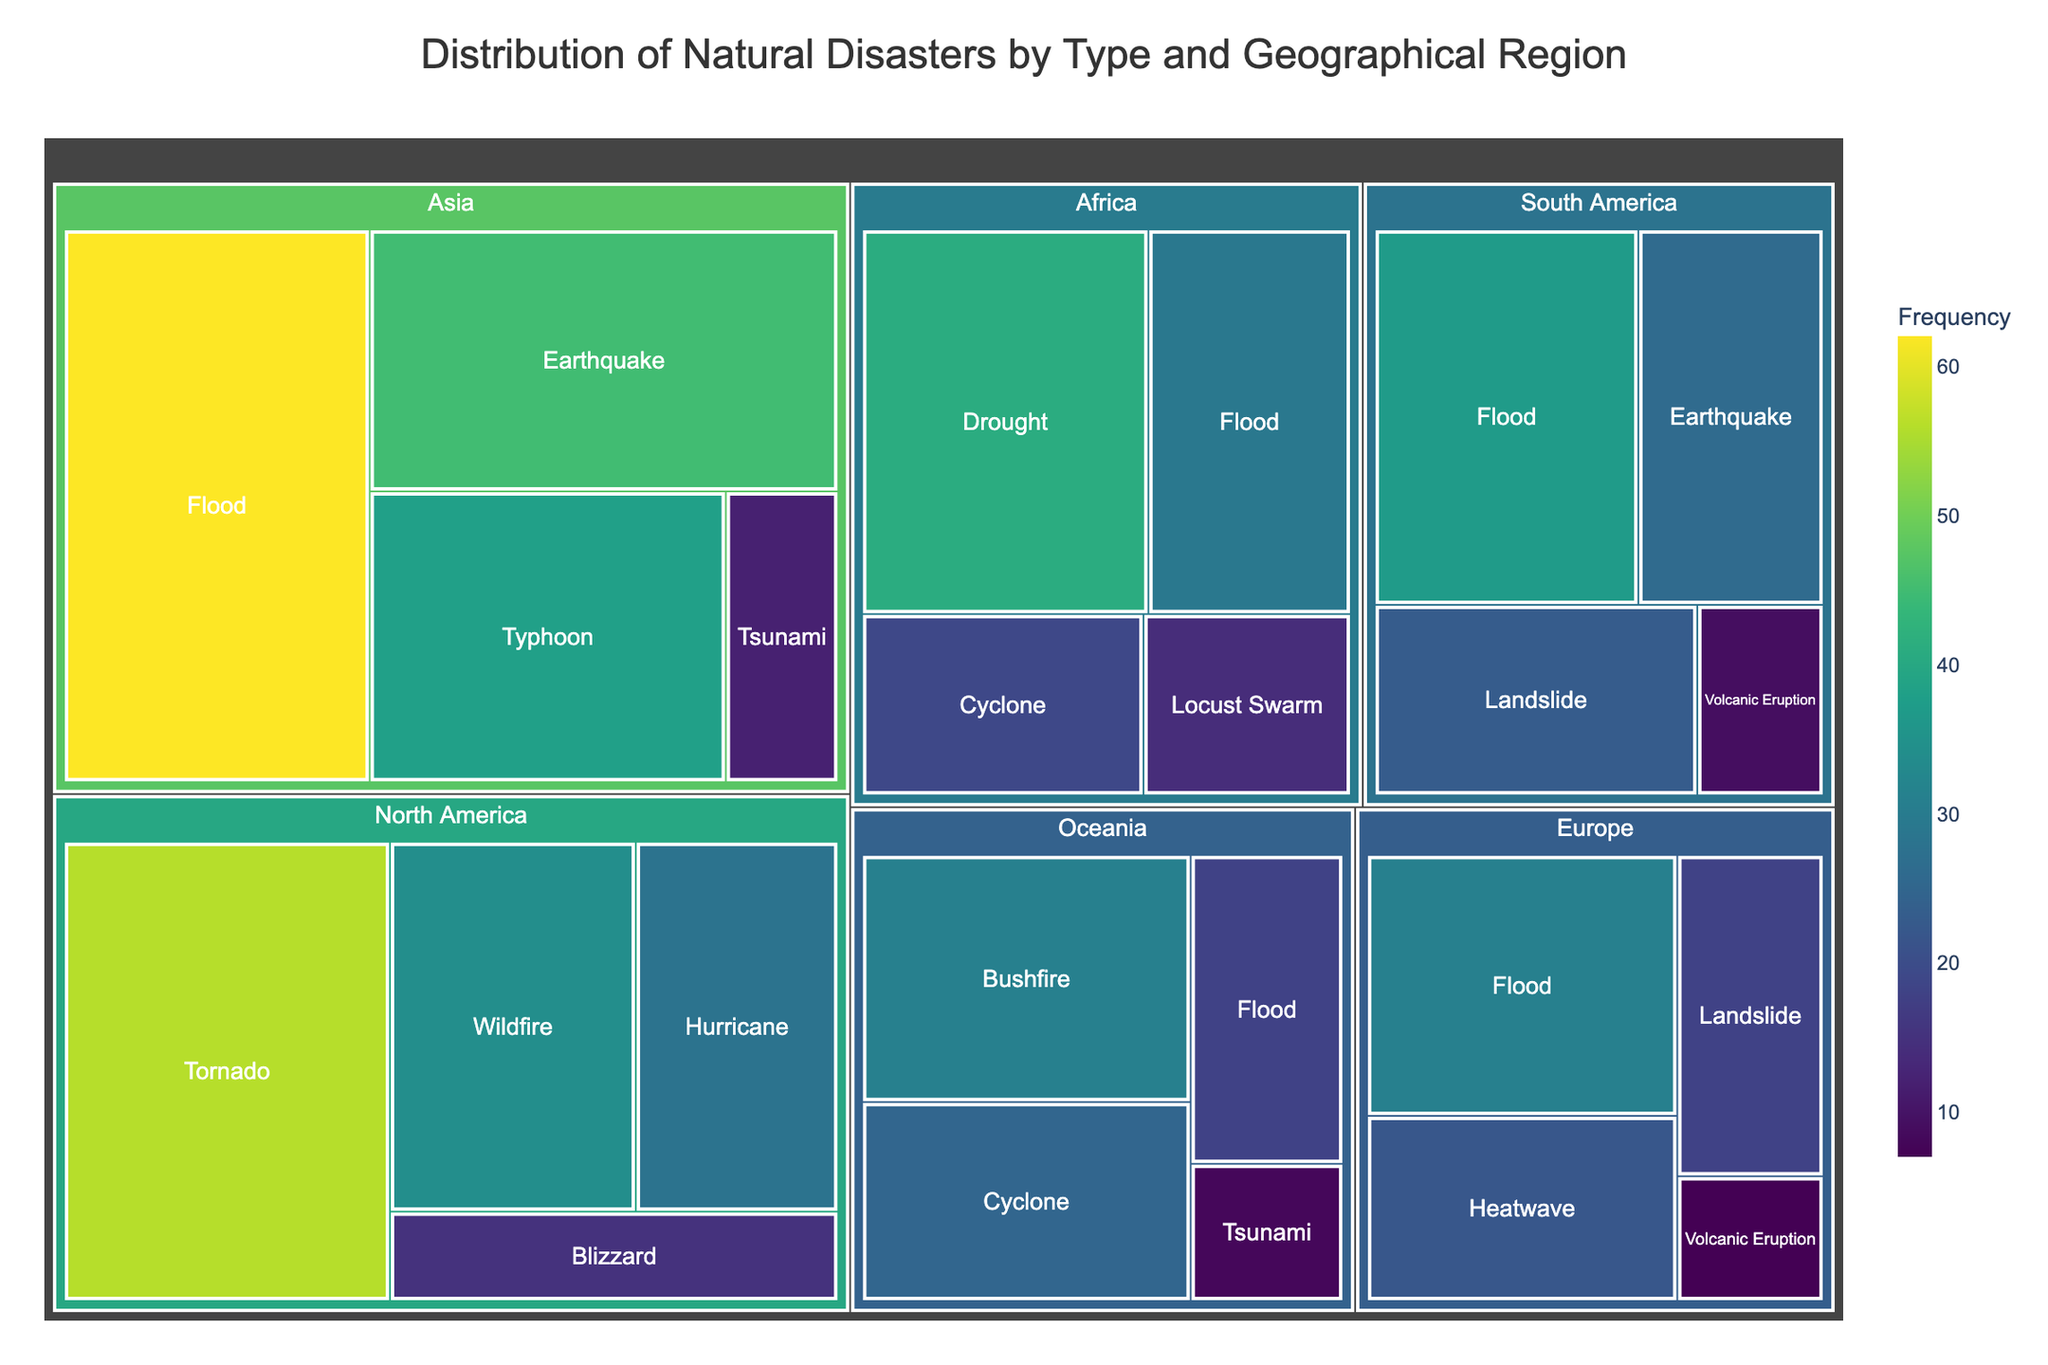What is the title of the plot? The title is located at the top of the Treemap and provides a summary of what the plot represents.
Answer: Distribution of Natural Disasters by Type and Geographical Region Which disaster type has the highest frequency in Asia? To find the answer, look at the Asia section of the Treemap and identify the disaster type with the largest area representing the highest frequency.
Answer: Flood Which region reports the most frequent earthquakes? Inspect the sections of the Treemap labeled by regions and identify the one with the largest area representing earthquakes.
Answer: Asia What is the combined frequency of cyclones in Africa and Oceania? Locate the frequencies of cyclones in Africa and Oceania sections of the Treemap. Add these numbers together: Africa (19) + Oceania (25) = 44
Answer: 44 How does the frequency of wildfires in North America compare to the frequency of bushfires in Oceania? Find the areas corresponding to wildfires in North America and bushfires in Oceania. Compare their sizes directly.
Answer: Wildfire (34) is greater than Bushfire (31) Which region has the fewest reported natural disasters and what is the specific type of disaster? Look for the smallest areas in the Treemap and identify the region and disaster type with the smallest frequency number.
Answer: Europe, Volcanic Eruption How many regions report floods, and what are their frequencies? Identify all sections of the Treemap representing floods, then count these sections and list their frequencies.
Answer: 4 regions (Asia: 62, Europe: 31, Africa: 29, Oceania: 18) What is the difference in frequency between tornadoes in North America and landslides in Europe? Identify and subtract the frequency of landslides in Europe from that of tornadoes in North America: (56 - 18 = 38).
Answer: 38 Which region has the highest diversity of disaster types, and which types are they? Count the number of different disaster types within each region in the Treemap. Identify the region with the largest count and list the disaster types.
Answer: Asia, (Earthquake, Typhoon, Flood, Tsunami) How does the frequency of typhoons in Asia compare to hurricanes in North America? Find and compare the areas corresponding to typhoons in Asia and hurricanes in North America.
Answer: Typhoon (38) is greater than Hurricane (28) 